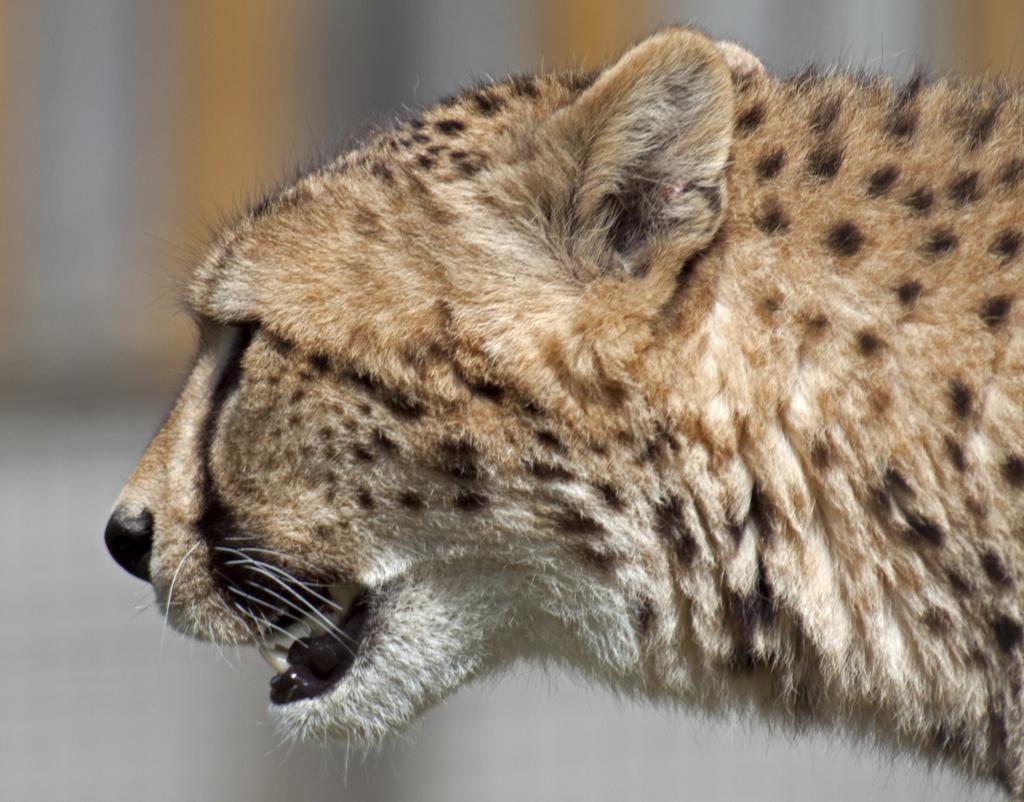In one or two sentences, can you explain what this image depicts? In the picture we can see a side view of a cheetah face and the background is not clear. 